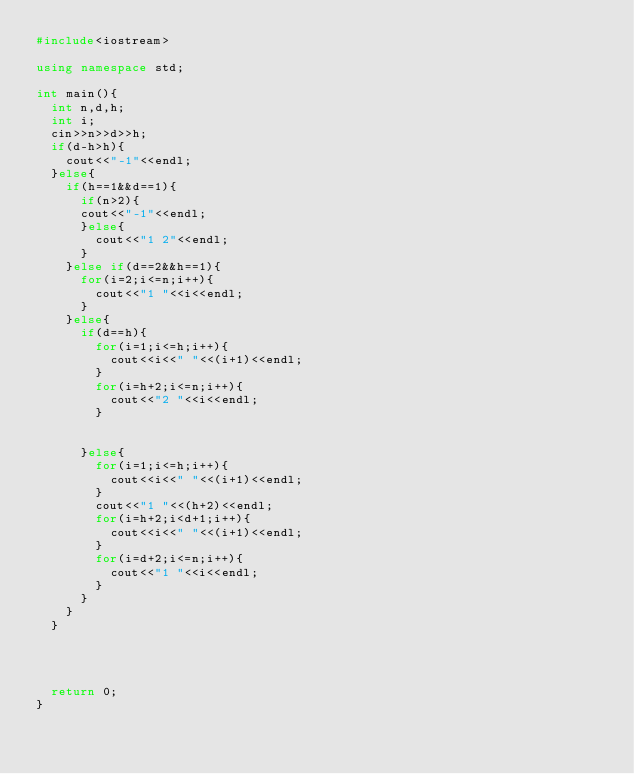Convert code to text. <code><loc_0><loc_0><loc_500><loc_500><_C++_>#include<iostream>

using namespace std;

int main(){
	int n,d,h;
	int i;
	cin>>n>>d>>h;
	if(d-h>h){
		cout<<"-1"<<endl;
	}else{
		if(h==1&&d==1){
			if(n>2){
			cout<<"-1"<<endl;
			}else{
				cout<<"1 2"<<endl;
			}
		}else if(d==2&&h==1){
			for(i=2;i<=n;i++){
				cout<<"1 "<<i<<endl;
			}
		}else{
			if(d==h){
				for(i=1;i<=h;i++){
					cout<<i<<" "<<(i+1)<<endl;
				}
				for(i=h+2;i<=n;i++){
					cout<<"2 "<<i<<endl;
				}


			}else{
				for(i=1;i<=h;i++){
					cout<<i<<" "<<(i+1)<<endl;
				}
				cout<<"1 "<<(h+2)<<endl;
				for(i=h+2;i<d+1;i++){
					cout<<i<<" "<<(i+1)<<endl;
				}
				for(i=d+2;i<=n;i++){
					cout<<"1 "<<i<<endl;
				}
			}
		}
	}




	return 0;
}</code> 